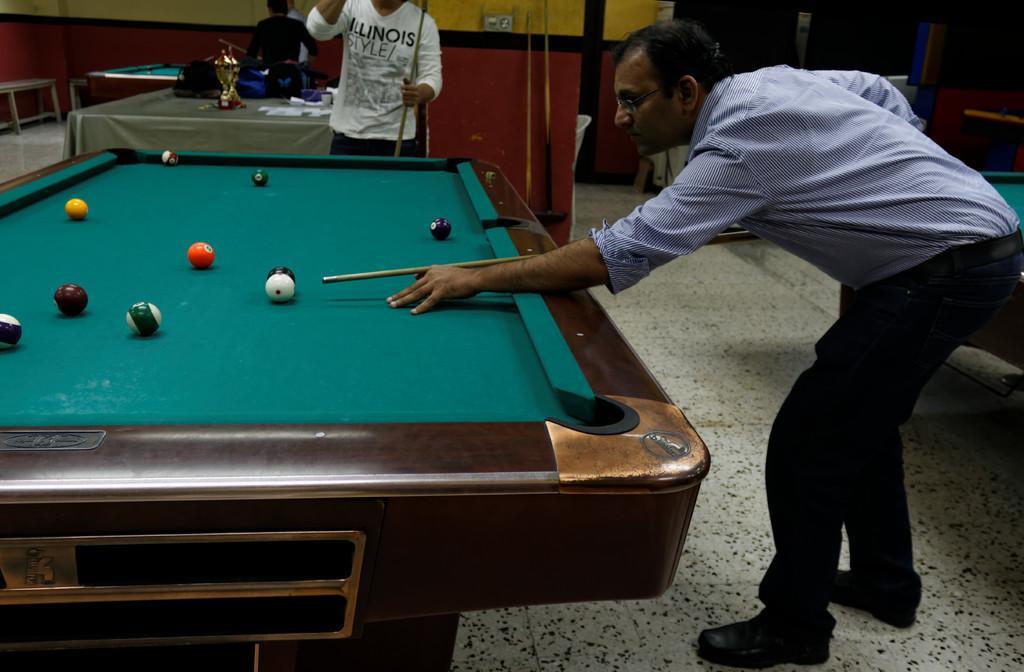Could you give a brief overview of what you see in this image? In this image, we can see some pool tables. On left side of the image, the man is holding a stick. He is playing a pool game. On top of the table, we can see few balls. Beside the table, the man is holding a stick. On top left of the image, the other table is covered with cloth and bags here, shield. And the background of the image, two people are standing near the table. 